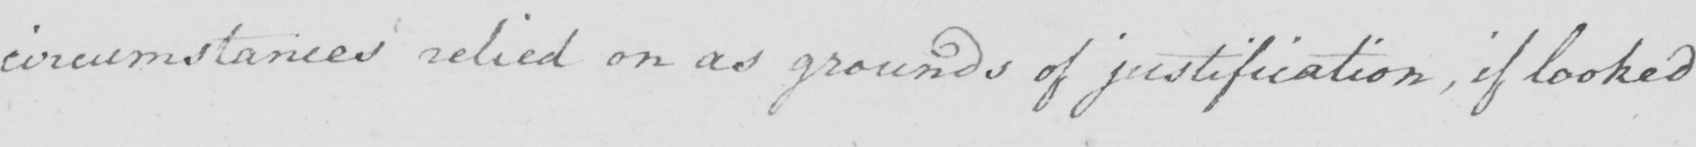Can you read and transcribe this handwriting? circumstances relied on as grounds of justification , if looked 